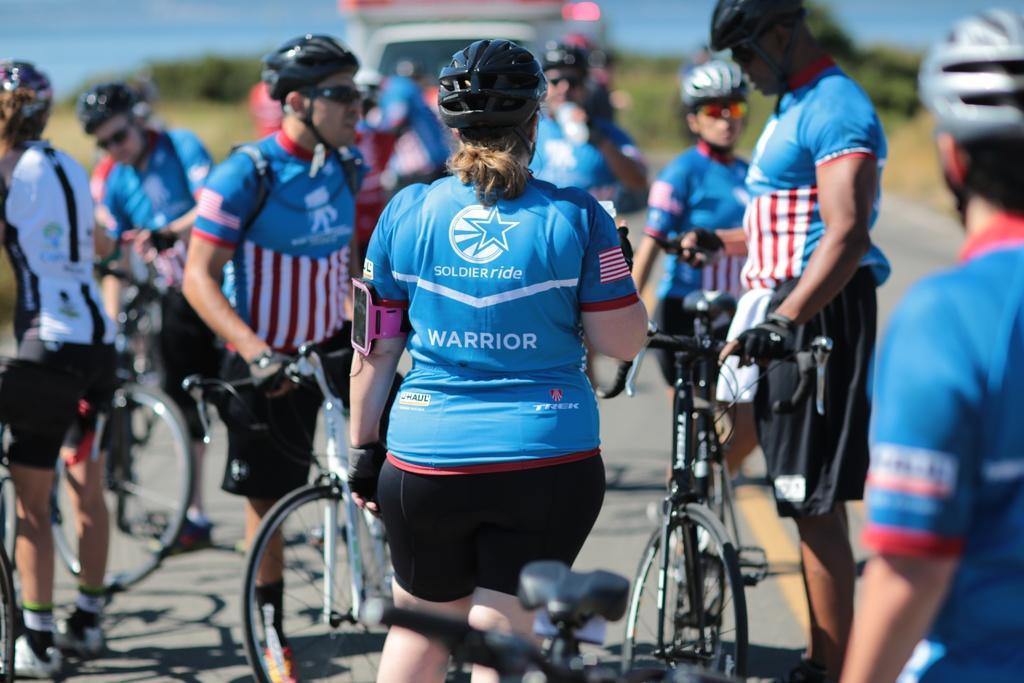Could you give a brief overview of what you see in this image? This picture shows many people sitting on a bicycle riding it. All of them are wearing helmets. Most of them were in blue color t-shirts. In the background, there are some trees and sky here. 